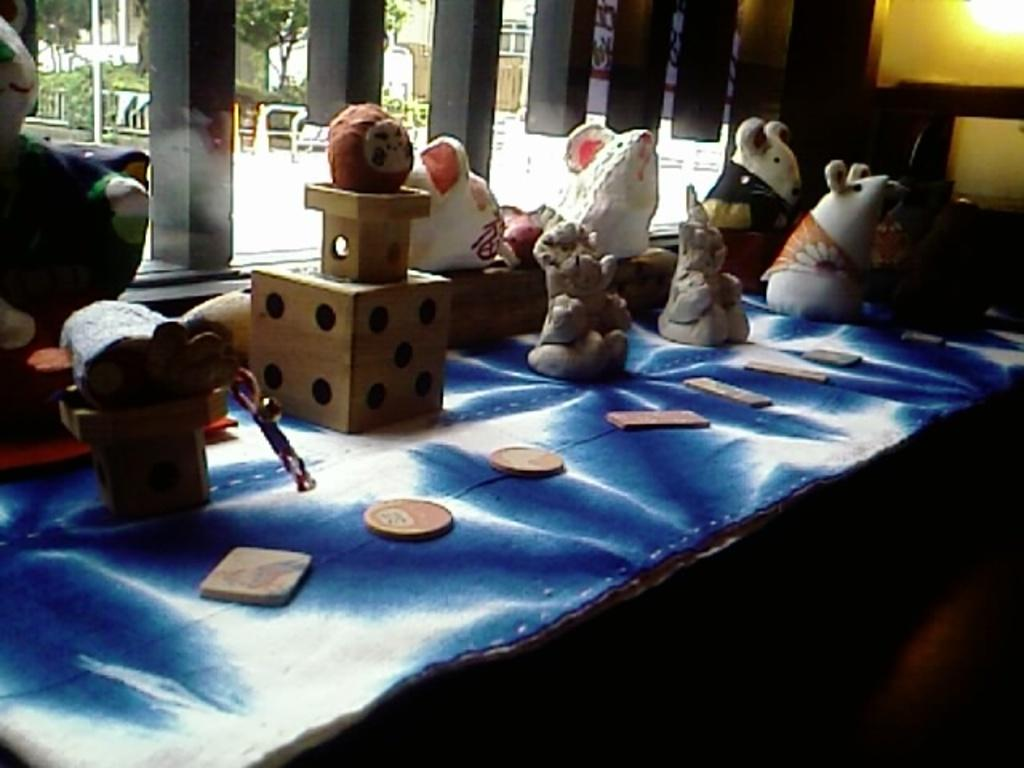What type of objects are in the image? There are earthenware objects in the image. Where are the earthenware objects located? The earthenware objects are placed on a table. Are the earthenware objects mass-produced or handmade? The earthenware objects are handmade. What can be seen in the background of the image? There are pillars and trees in the background of the image. What type of linen is draped over the earthenware objects in the image? There is no linen draped over the earthenware objects in the image. What advice can be given to the person who made the earthenware objects in the image? The image does not provide enough information to give advice to the person who made the earthenware objects. What type of pickle is being served with the earthenware objects in the image? There is no pickle present in the image. 